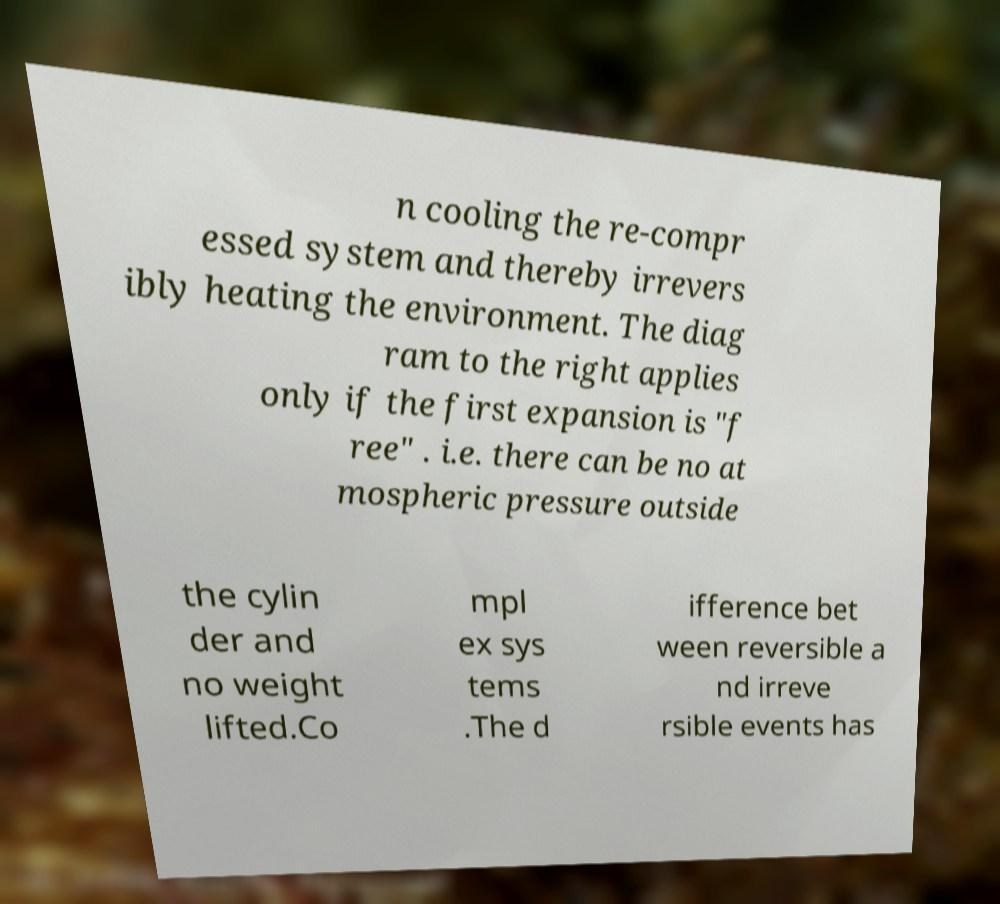Can you read and provide the text displayed in the image?This photo seems to have some interesting text. Can you extract and type it out for me? n cooling the re-compr essed system and thereby irrevers ibly heating the environment. The diag ram to the right applies only if the first expansion is "f ree" . i.e. there can be no at mospheric pressure outside the cylin der and no weight lifted.Co mpl ex sys tems .The d ifference bet ween reversible a nd irreve rsible events has 